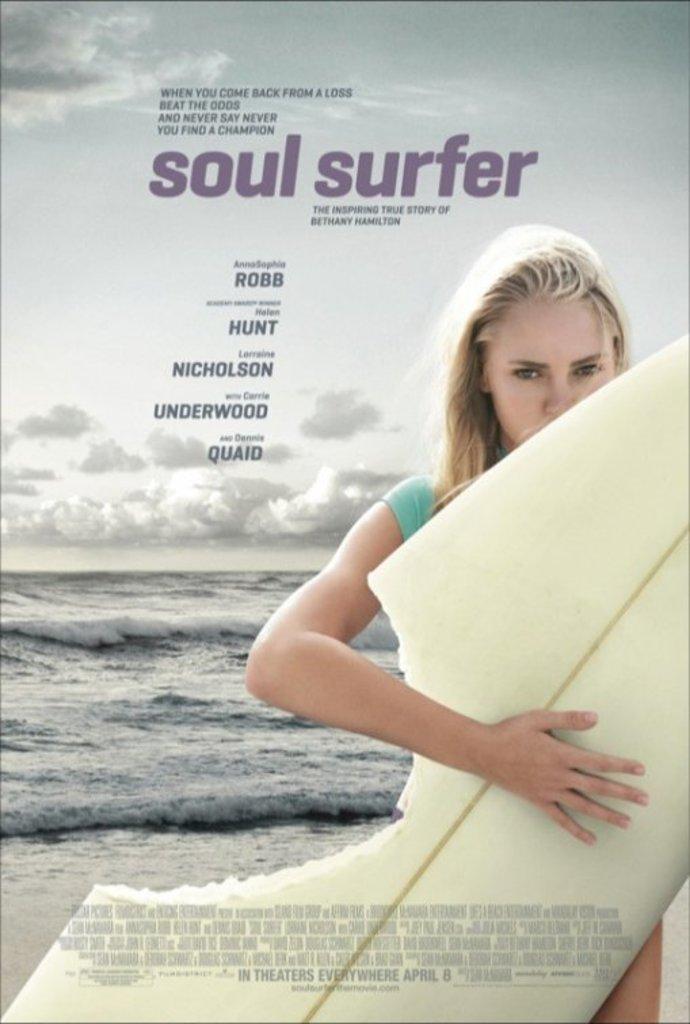In one or two sentences, can you explain what this image depicts? In this image there is a lady person standing and holding surfing board and at the background of the image there is a water and cloudy sky. 